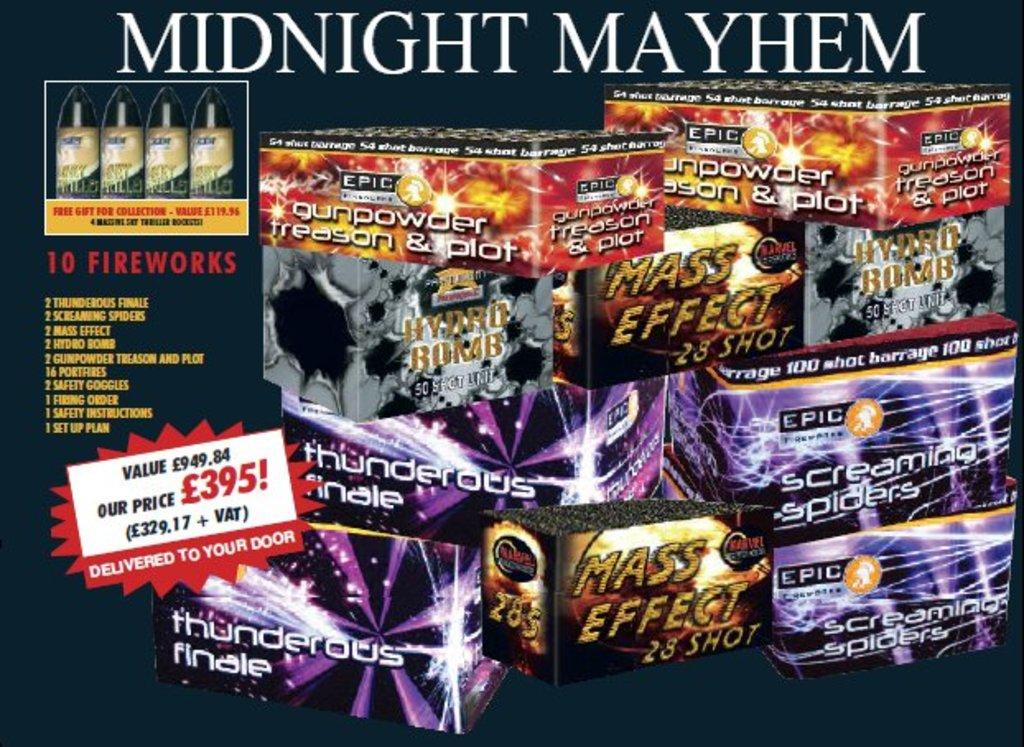What can be found in the image? There are objects, text, and numbers in the image. Can you describe the background of the image? The background of the image is dark. Is there an umbrella visible in the image? There is no mention of an umbrella in the provided facts, so it cannot be determined if one is present in the image. Can you tell me how many beetles are crawling on the text in the image? There is no mention of beetles in the provided facts, so it cannot be determined if any are present in the image. 